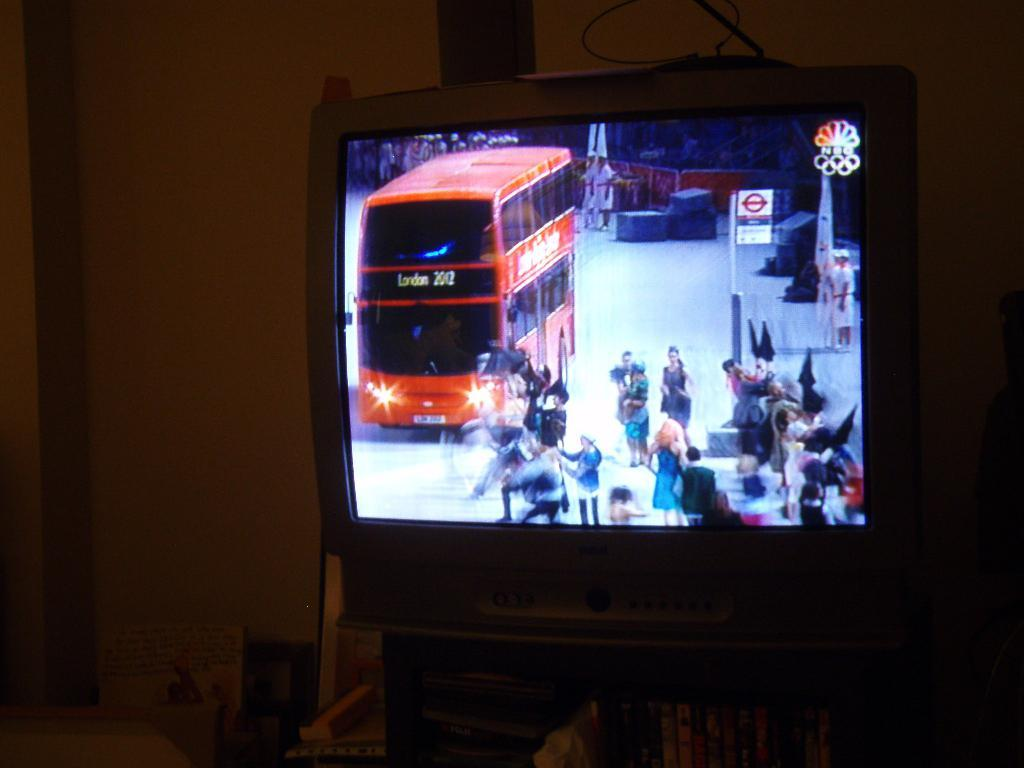Provide a one-sentence caption for the provided image. The television channel on is NBC and is covering the London Olympics. 